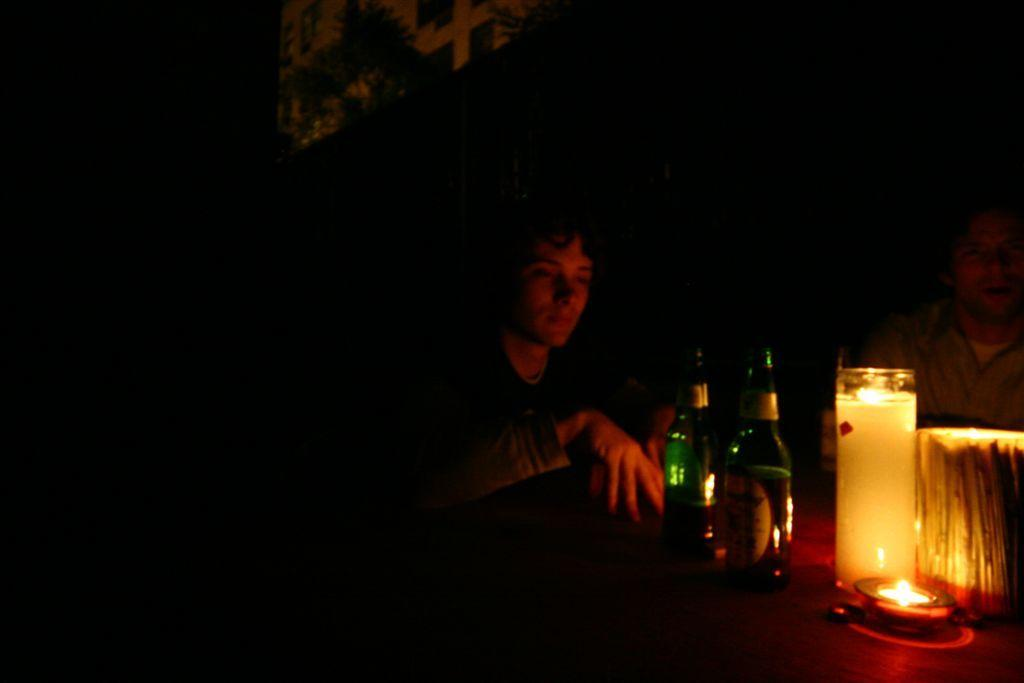How many people are in the image? There are two people in the image. What objects are in front of the people? There are bottles, a candle, and other things in front of the people. What is the lighting condition in the image? The background of the image is dark. What type of rake is being used by the people in the image? There is no rake present in the image. What kind of apparatus is being used by the people in the image? The provided facts do not mention any specific apparatus being used by the people in the image. 